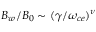<formula> <loc_0><loc_0><loc_500><loc_500>B _ { w } / B _ { 0 } \sim ( \gamma / \omega _ { c e } ) ^ { \nu }</formula> 